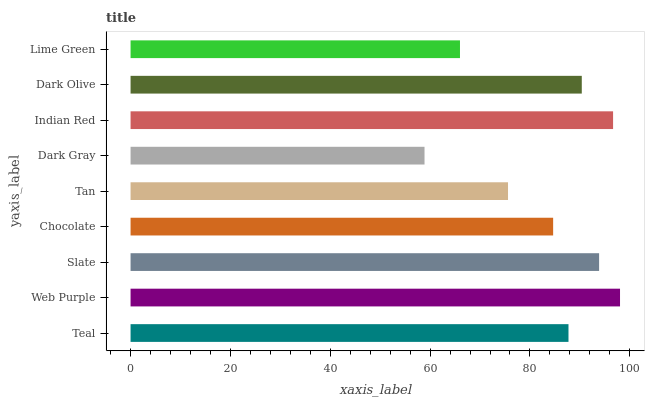Is Dark Gray the minimum?
Answer yes or no. Yes. Is Web Purple the maximum?
Answer yes or no. Yes. Is Slate the minimum?
Answer yes or no. No. Is Slate the maximum?
Answer yes or no. No. Is Web Purple greater than Slate?
Answer yes or no. Yes. Is Slate less than Web Purple?
Answer yes or no. Yes. Is Slate greater than Web Purple?
Answer yes or no. No. Is Web Purple less than Slate?
Answer yes or no. No. Is Teal the high median?
Answer yes or no. Yes. Is Teal the low median?
Answer yes or no. Yes. Is Tan the high median?
Answer yes or no. No. Is Indian Red the low median?
Answer yes or no. No. 